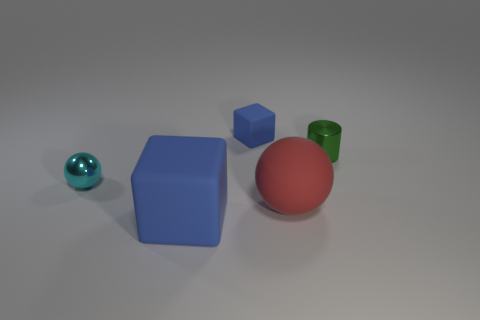Add 1 yellow metallic spheres. How many objects exist? 6 Subtract all spheres. How many objects are left? 3 Add 3 small blue matte cubes. How many small blue matte cubes exist? 4 Subtract 0 purple cylinders. How many objects are left? 5 Subtract all purple objects. Subtract all red rubber balls. How many objects are left? 4 Add 3 cyan spheres. How many cyan spheres are left? 4 